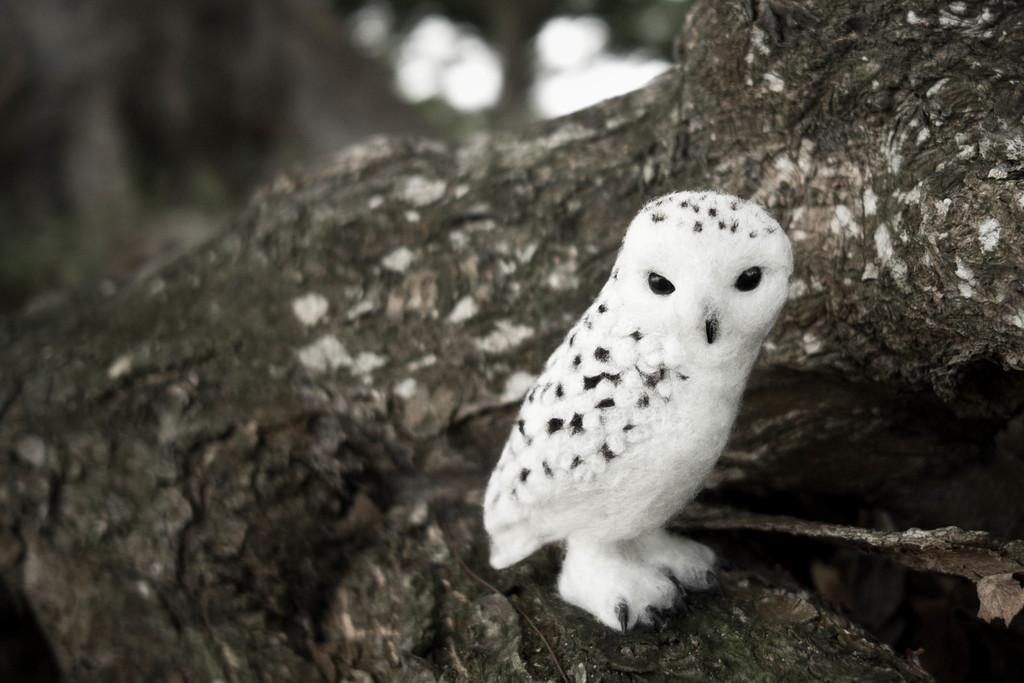What animal can be seen in the image? There is an owl in the image. Where is the owl located? The owl is standing on a tree branch. What is the nature of the blurry image at the top of the image? Unfortunately, the details of the blurry image cannot be determined from the provided facts. What type of birth apparatus is visible in the image? There is no birth apparatus present in the image; it features an owl standing on a tree branch. 